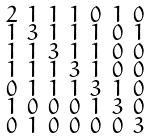<formula> <loc_0><loc_0><loc_500><loc_500>\begin{smallmatrix} 2 & 1 & 1 & 1 & 0 & 1 & 0 \\ 1 & 3 & 1 & 1 & 1 & 0 & 1 \\ 1 & 1 & 3 & 1 & 1 & 0 & 0 \\ 1 & 1 & 1 & 3 & 1 & 0 & 0 \\ 0 & 1 & 1 & 1 & 3 & 1 & 0 \\ 1 & 0 & 0 & 0 & 1 & 3 & 0 \\ 0 & 1 & 0 & 0 & 0 & 0 & 3 \end{smallmatrix}</formula> 